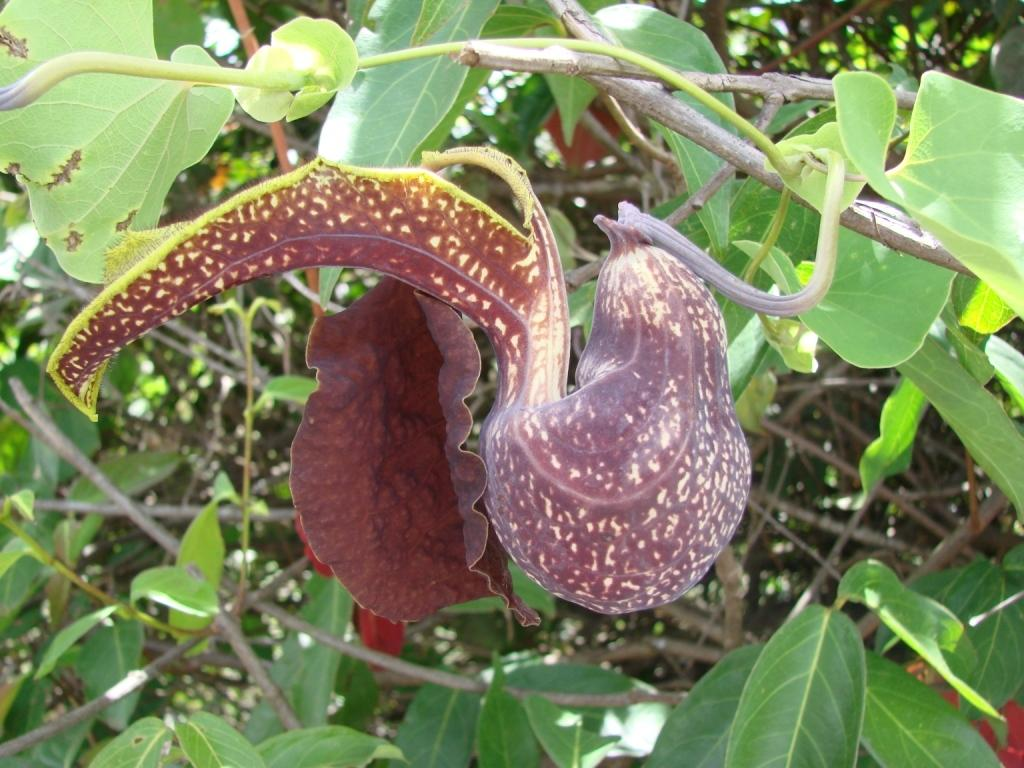What type of plant material is present in the image? There are leaves of a plant in the image. What colors can be seen on the leaves? The leaves are brown and green in color. What else can be seen in the background of the image? There are other plants visible in the background of the image. What route does the fireman take to reach the leaves in the image? There is no fireman or route present in the image; it only features leaves of a plant and other plants in the background. 